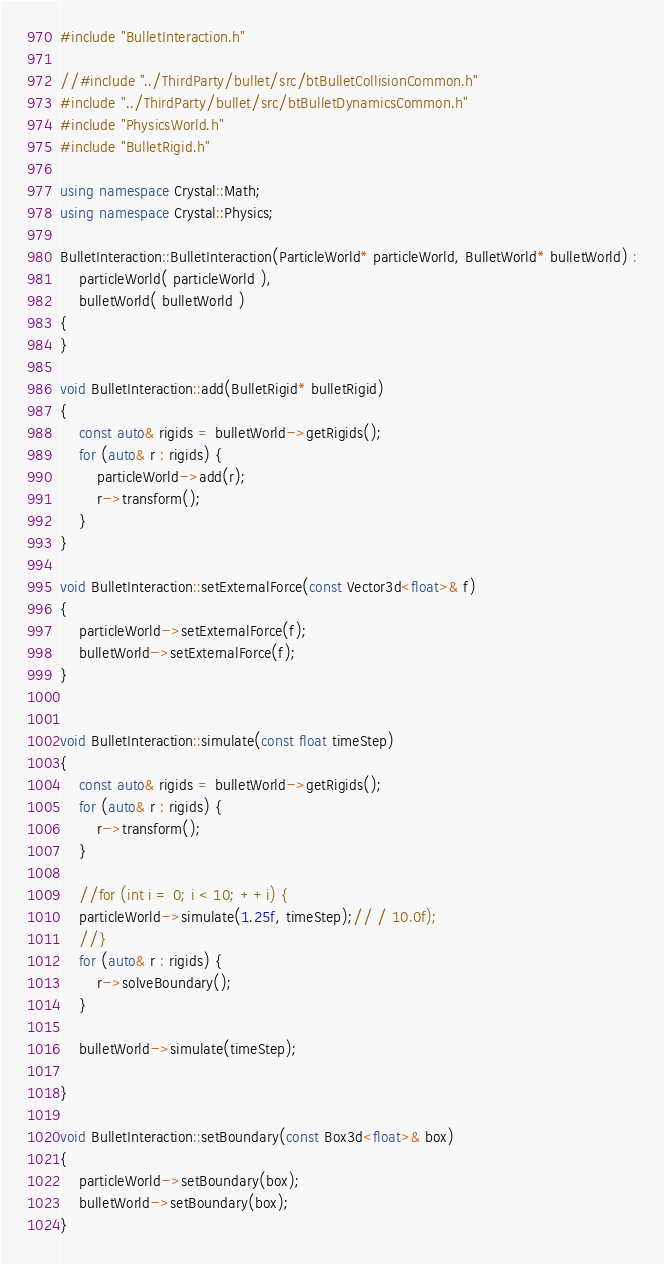<code> <loc_0><loc_0><loc_500><loc_500><_C++_>#include "BulletInteraction.h"

//#include "../ThirdParty/bullet/src/btBulletCollisionCommon.h"
#include "../ThirdParty/bullet/src/btBulletDynamicsCommon.h"
#include "PhysicsWorld.h"
#include "BulletRigid.h"

using namespace Crystal::Math;
using namespace Crystal::Physics;

BulletInteraction::BulletInteraction(ParticleWorld* particleWorld, BulletWorld* bulletWorld) :
	particleWorld( particleWorld ),
	bulletWorld( bulletWorld )
{
}

void BulletInteraction::add(BulletRigid* bulletRigid)
{
	const auto& rigids = bulletWorld->getRigids();
	for (auto& r : rigids) {
		particleWorld->add(r);
		r->transform();
	}
}

void BulletInteraction::setExternalForce(const Vector3d<float>& f)
{
	particleWorld->setExternalForce(f);
	bulletWorld->setExternalForce(f);
}


void BulletInteraction::simulate(const float timeStep)
{
	const auto& rigids = bulletWorld->getRigids();
	for (auto& r : rigids) {
		r->transform();
	}

	//for (int i = 0; i < 10; ++i) {
	particleWorld->simulate(1.25f, timeStep);// / 10.0f);
	//}
	for (auto& r : rigids) {
		r->solveBoundary();
	}

	bulletWorld->simulate(timeStep);

}

void BulletInteraction::setBoundary(const Box3d<float>& box)
{
	particleWorld->setBoundary(box);
	bulletWorld->setBoundary(box);
}
</code> 